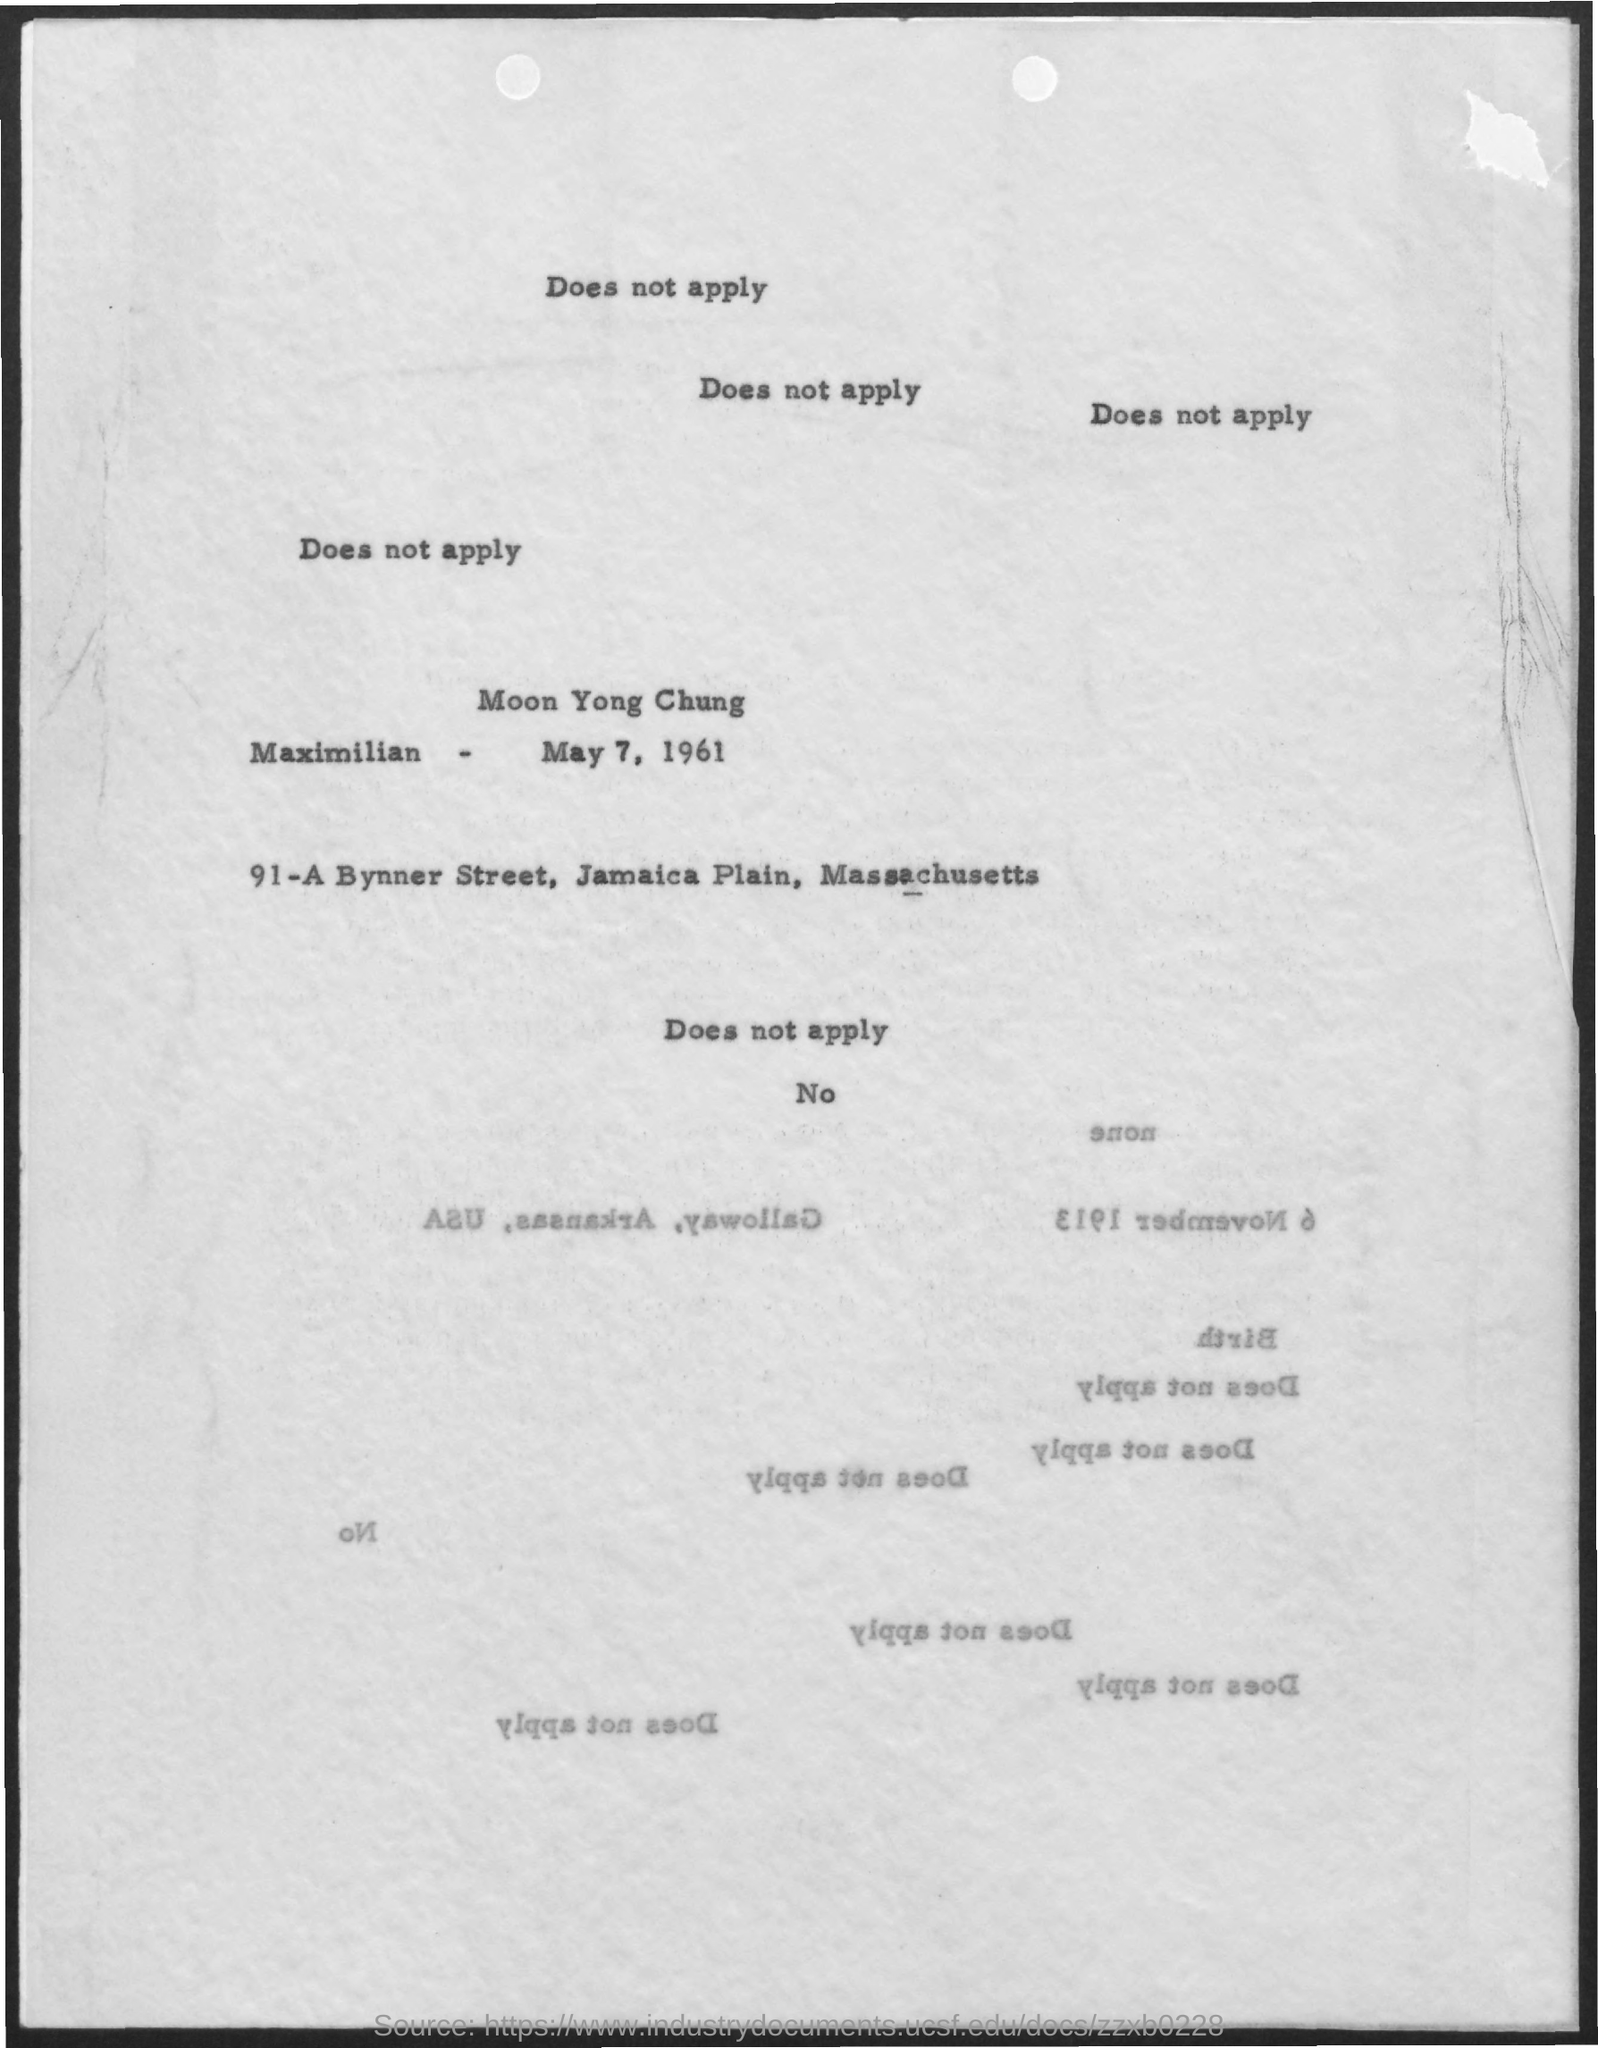Mention a couple of crucial points in this snapshot. The date mentioned in the given page is May 7, 1961. 